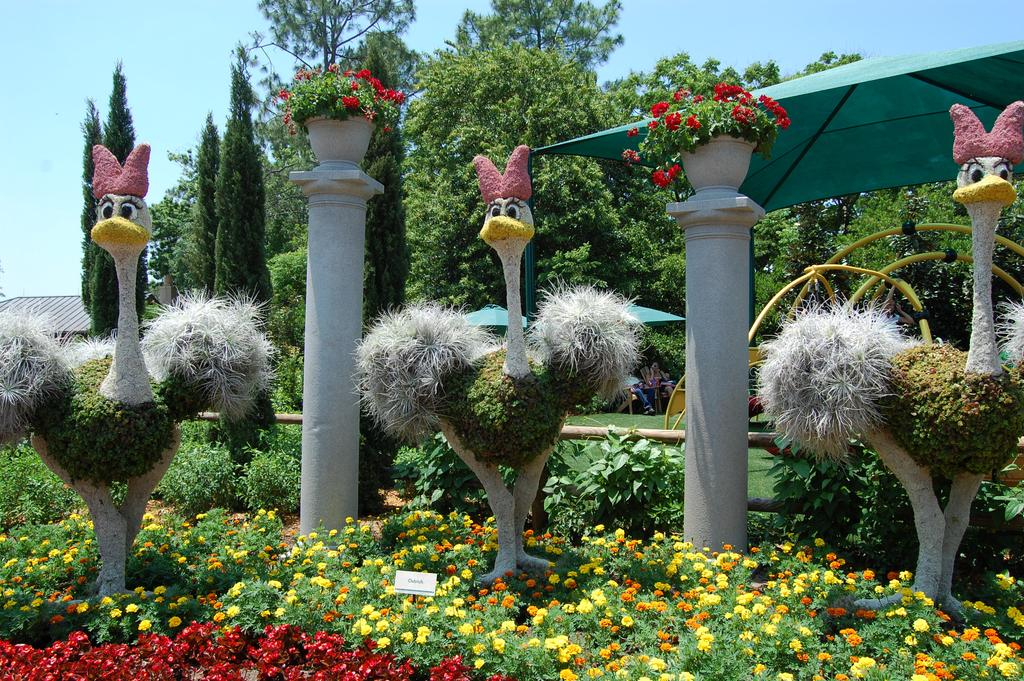What type of plants can be seen in the image? There are plants with flowers in the image. Where are the plants located in relation to the image? The plants are located at the bottom of the image. What can be seen in the background of the image? There are trees in the background of the image. What is visible at the top of the image? The sky is visible at the top of the image. What type of rod is used to measure the friction between the plants and the ground in the image? There is no rod or measurement of friction present in the image; it simply shows plants with flowers. 